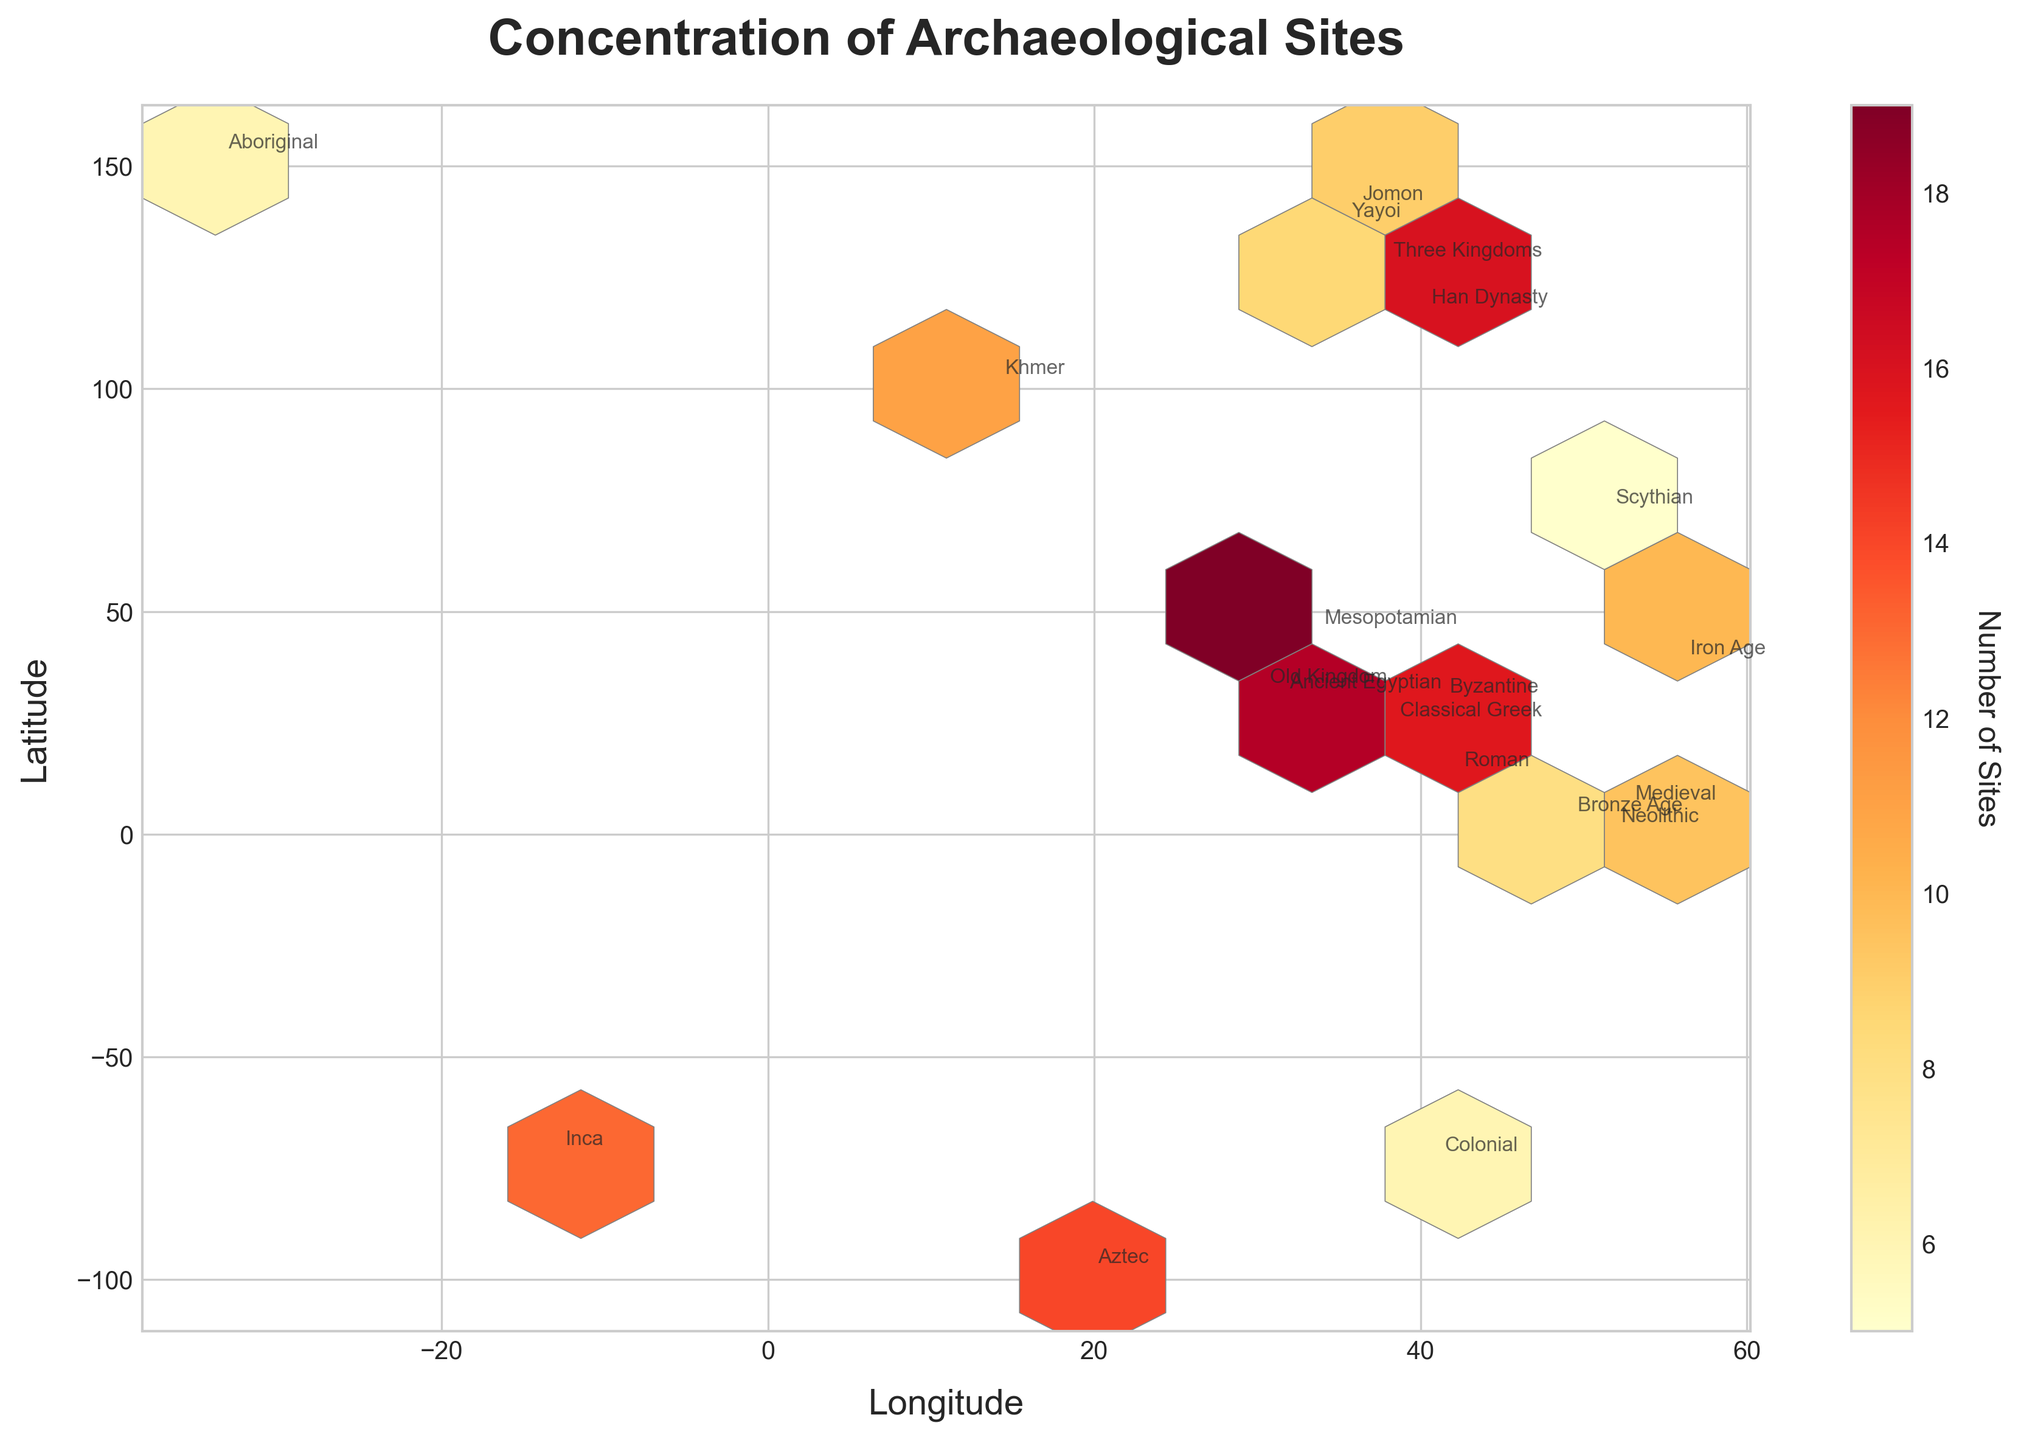what is the title of the figure? The title is displayed at the top of the figure in large, bold font.
Answer: Concentration of Archaeological Sites what do the x and y axes represent? The x-axis represents Longitude, and the y-axis represents Latitude, which are labeled on the bottom and left sides respectively.
Answer: Longitude and Latitude what is the color used to represent the most concentrated areas of archaeological sites? The color used for the most concentrated areas is dark red. This is evident from the color gradient depicted on the plot and the color bar on the side.
Answer: Dark Red how many historical periods are annotated on the plot? There are 19 historical periods annotated on the plot, as each data point is labeled with its corresponding period. These annotations are visible at the coordinates of each site.
Answer: 19 which historical period has the highest number of archaeological sites? The period with the highest site count is represented by the largest number in the color bar. In this case, the Classical Greek period has 20 sites.
Answer: Classical Greek what is the median site count among all historical periods shown? Listing the site counts: 12, 8, 15, 20, 6, 18, 9, 14, 11, 7, 10, 16, 8, 5, 13, 17, 9, 12, 19, 6. The median, being the middle value in the ordered list, is (10 + 11)/2 = 10.5, as there’s an even number of periods.
Answer: 10.5 which two periods are located closest to each other by their coordinates? Looking at the coordinates where the period names are annotated, the Byzantine (41.0082, 28.9784) and Roman periods (41.9028, 12.4964) are closest in proximity. These locations are in close geographical regions.
Answer: Byzantine and Roman are there more archaeological sites found in the Northern Hemisphere or the Southern Hemisphere? By counting annotated periods by hemisphere: Northern (12, 8, 15, 20, 6, 18, 9, 14, 11, 7, 10, 16, 8, 5, 13, 9, 12, 19), Southern (6, 19). Northern has a clear majority.
Answer: Northern Hemisphere how does the site count for the Han Dynasty compare with the Old Kingdom? Han Dynasty has a site count of 16, and Old Kingdom has a site count of 17. Han Dynasty has one less than Old Kingdom.
Answer: Han Dynasty has 1 less than Old Kingdom what does the color bar represent? The color bar represents the number of archaeological sites, where different shades (from light yellow to dark red) indicate varying numbers of sites.
Answer: Number of Sites 